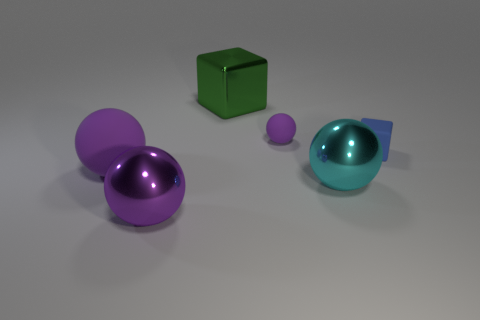Subtract all gray cylinders. How many purple spheres are left? 3 Add 2 large cyan metal cubes. How many objects exist? 8 Subtract all spheres. How many objects are left? 2 Subtract 1 green cubes. How many objects are left? 5 Subtract all large metallic objects. Subtract all tiny blue matte cylinders. How many objects are left? 3 Add 3 big matte balls. How many big matte balls are left? 4 Add 2 cylinders. How many cylinders exist? 2 